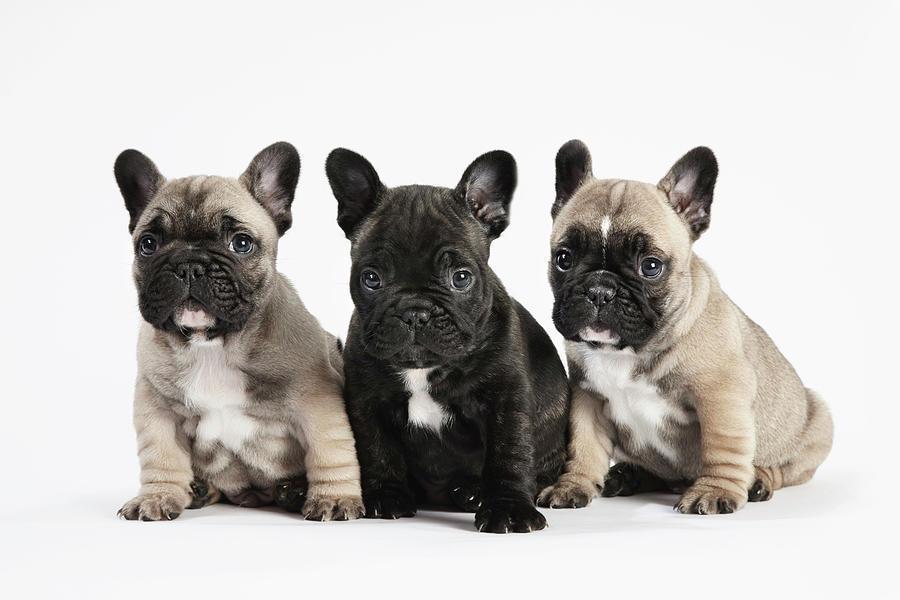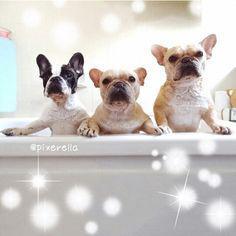The first image is the image on the left, the second image is the image on the right. Evaluate the accuracy of this statement regarding the images: "Each image shows a horizontal row of three flat-faced dogs, and the right image shows the dogs leaning on a white ledge.". Is it true? Answer yes or no. Yes. 